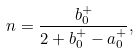Convert formula to latex. <formula><loc_0><loc_0><loc_500><loc_500>n = \frac { b _ { 0 } ^ { + } } { 2 + b _ { 0 } ^ { + } - a _ { 0 } ^ { + } } ,</formula> 